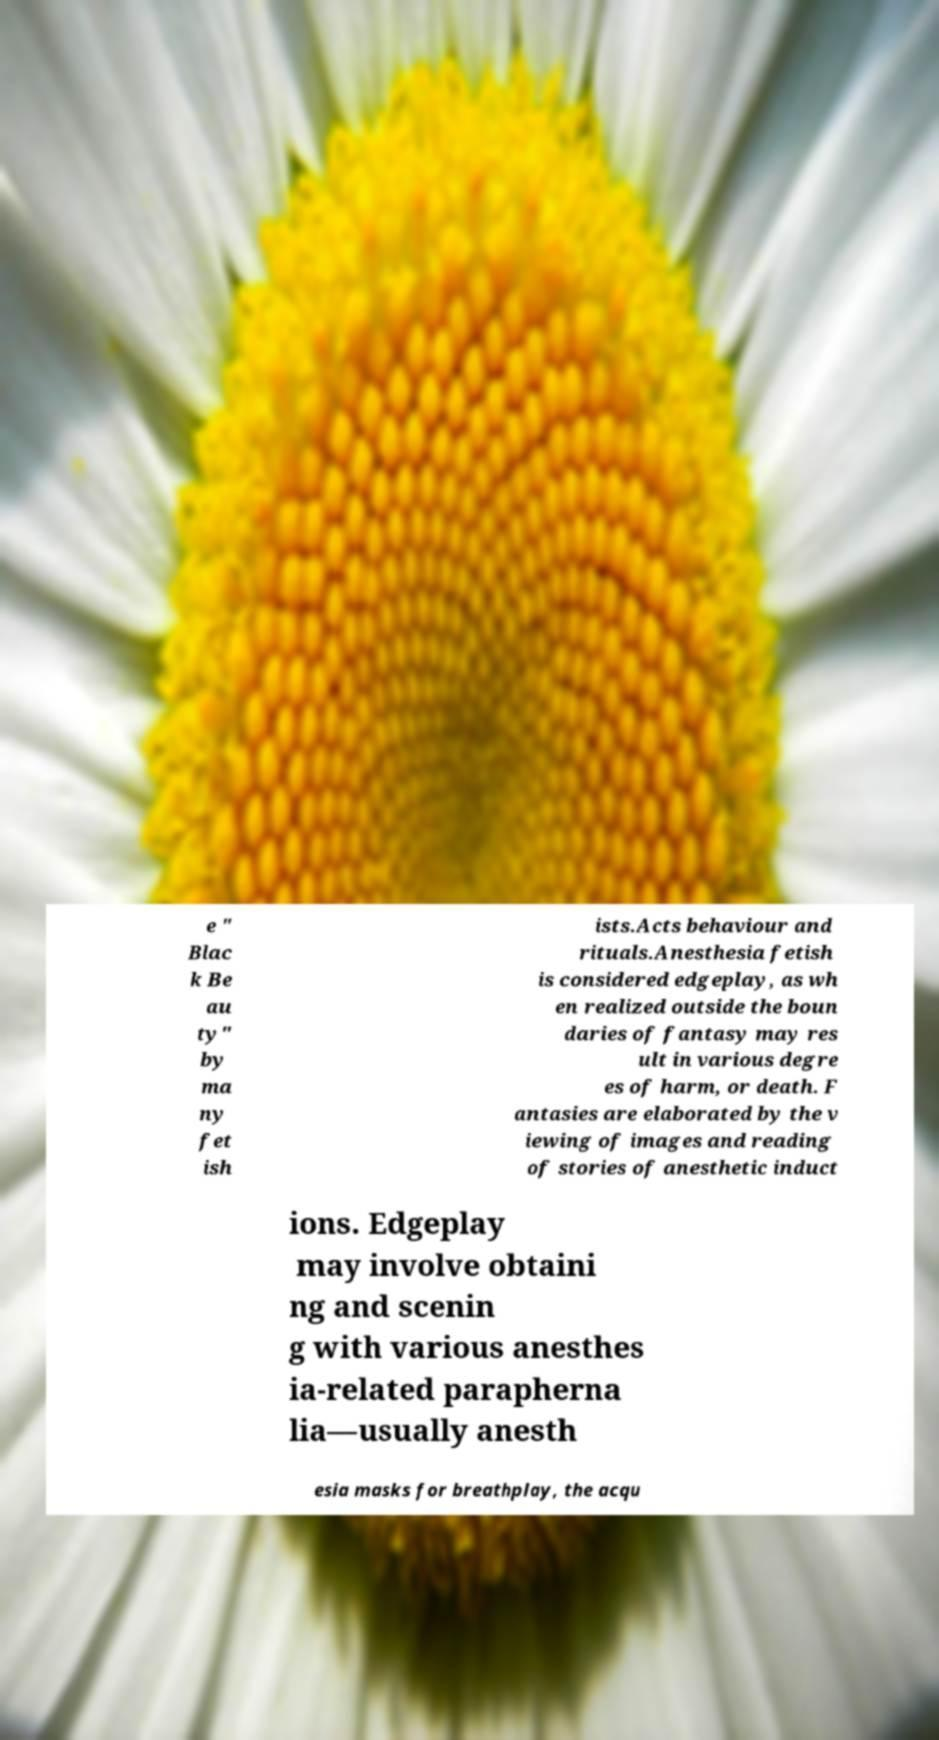Can you read and provide the text displayed in the image?This photo seems to have some interesting text. Can you extract and type it out for me? e " Blac k Be au ty" by ma ny fet ish ists.Acts behaviour and rituals.Anesthesia fetish is considered edgeplay, as wh en realized outside the boun daries of fantasy may res ult in various degre es of harm, or death. F antasies are elaborated by the v iewing of images and reading of stories of anesthetic induct ions. Edgeplay may involve obtaini ng and scenin g with various anesthes ia-related parapherna lia—usually anesth esia masks for breathplay, the acqu 